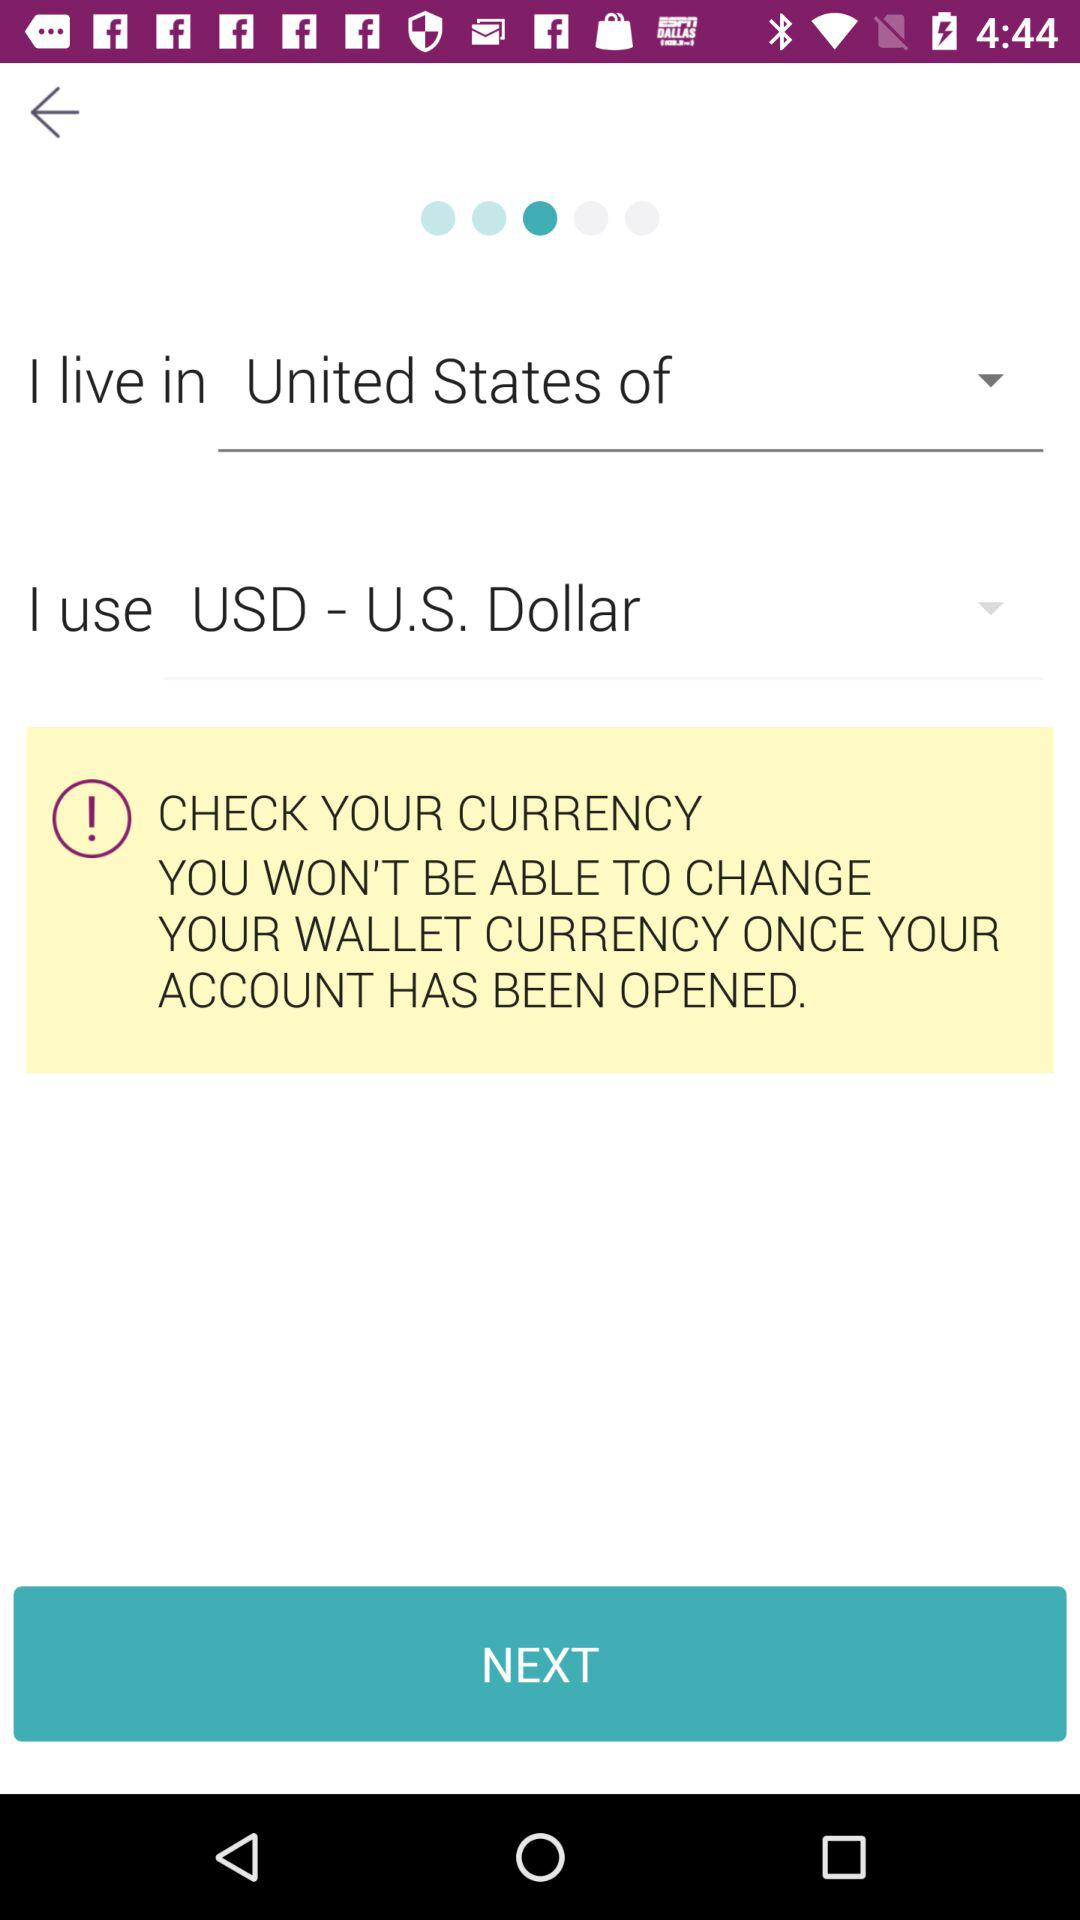Which city does the user live in?
When the provided information is insufficient, respond with <no answer>. <no answer> 